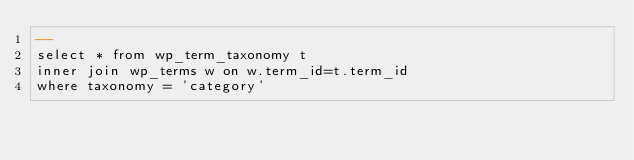Convert code to text. <code><loc_0><loc_0><loc_500><loc_500><_SQL_>--
select * from wp_term_taxonomy t
inner join wp_terms w on w.term_id=t.term_id
where taxonomy = 'category'


</code> 